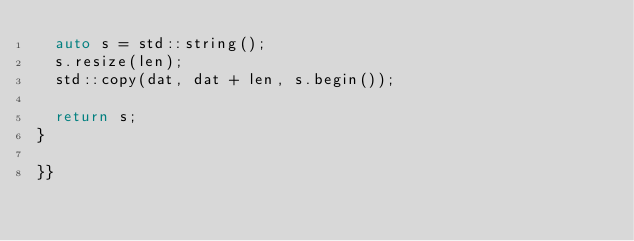<code> <loc_0><loc_0><loc_500><loc_500><_C++_>	auto s = std::string();
	s.resize(len);
	std::copy(dat, dat + len, s.begin());

	return s;
}

}}
</code> 